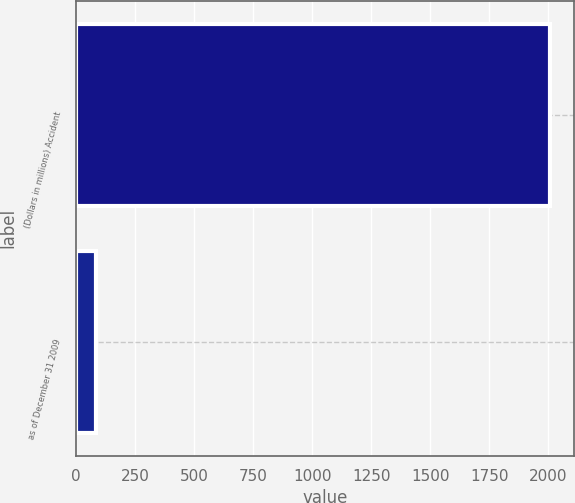Convert chart. <chart><loc_0><loc_0><loc_500><loc_500><bar_chart><fcel>(Dollars in millions) Accident<fcel>as of December 31 2009<nl><fcel>2008<fcel>83.4<nl></chart> 